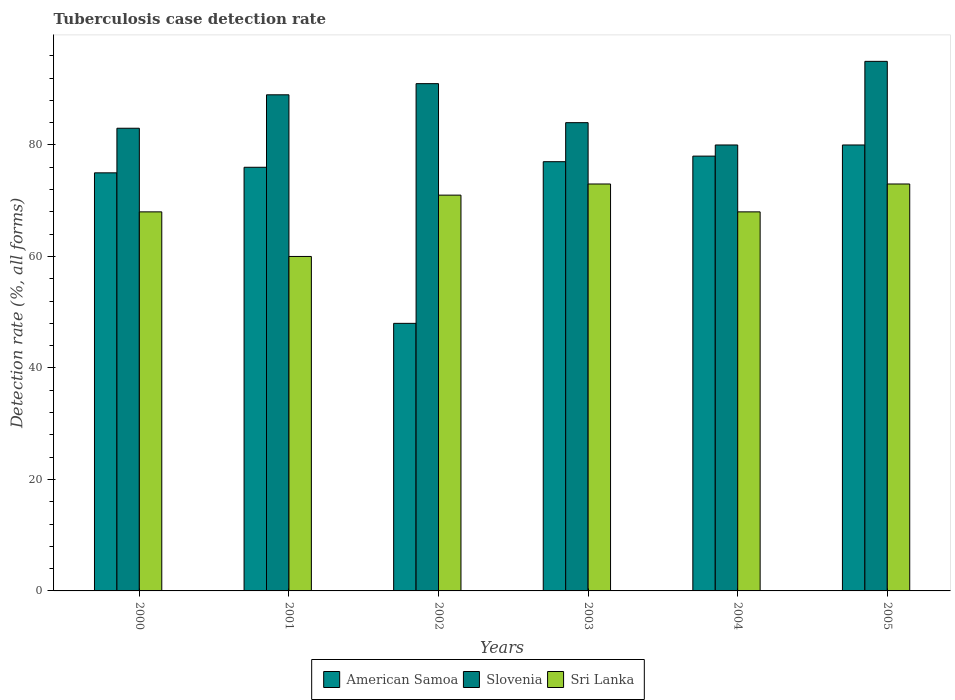How many different coloured bars are there?
Offer a very short reply. 3. How many groups of bars are there?
Ensure brevity in your answer.  6. Are the number of bars on each tick of the X-axis equal?
Provide a short and direct response. Yes. How many bars are there on the 5th tick from the right?
Offer a very short reply. 3. What is the label of the 5th group of bars from the left?
Give a very brief answer. 2004. In how many cases, is the number of bars for a given year not equal to the number of legend labels?
Provide a short and direct response. 0. What is the tuberculosis case detection rate in in American Samoa in 2005?
Offer a terse response. 80. Across all years, what is the minimum tuberculosis case detection rate in in American Samoa?
Keep it short and to the point. 48. In which year was the tuberculosis case detection rate in in Slovenia maximum?
Provide a short and direct response. 2005. What is the total tuberculosis case detection rate in in Sri Lanka in the graph?
Give a very brief answer. 413. What is the difference between the tuberculosis case detection rate in in Sri Lanka in 2001 and that in 2002?
Offer a very short reply. -11. What is the difference between the tuberculosis case detection rate in in American Samoa in 2003 and the tuberculosis case detection rate in in Slovenia in 2002?
Provide a short and direct response. -14. What is the average tuberculosis case detection rate in in American Samoa per year?
Offer a terse response. 72.33. In the year 2000, what is the difference between the tuberculosis case detection rate in in American Samoa and tuberculosis case detection rate in in Sri Lanka?
Your answer should be very brief. 7. In how many years, is the tuberculosis case detection rate in in Sri Lanka greater than 84 %?
Offer a terse response. 0. What is the ratio of the tuberculosis case detection rate in in Slovenia in 2000 to that in 2004?
Provide a succinct answer. 1.04. Is the difference between the tuberculosis case detection rate in in American Samoa in 2000 and 2004 greater than the difference between the tuberculosis case detection rate in in Sri Lanka in 2000 and 2004?
Give a very brief answer. No. What is the difference between the highest and the second highest tuberculosis case detection rate in in American Samoa?
Provide a succinct answer. 2. In how many years, is the tuberculosis case detection rate in in Slovenia greater than the average tuberculosis case detection rate in in Slovenia taken over all years?
Your answer should be compact. 3. Is the sum of the tuberculosis case detection rate in in American Samoa in 2003 and 2004 greater than the maximum tuberculosis case detection rate in in Sri Lanka across all years?
Make the answer very short. Yes. What does the 3rd bar from the left in 2000 represents?
Offer a very short reply. Sri Lanka. What does the 2nd bar from the right in 2005 represents?
Your response must be concise. Slovenia. Is it the case that in every year, the sum of the tuberculosis case detection rate in in Slovenia and tuberculosis case detection rate in in American Samoa is greater than the tuberculosis case detection rate in in Sri Lanka?
Provide a succinct answer. Yes. Are all the bars in the graph horizontal?
Give a very brief answer. No. What is the difference between two consecutive major ticks on the Y-axis?
Provide a succinct answer. 20. How are the legend labels stacked?
Offer a terse response. Horizontal. What is the title of the graph?
Give a very brief answer. Tuberculosis case detection rate. Does "Pacific island small states" appear as one of the legend labels in the graph?
Your response must be concise. No. What is the label or title of the Y-axis?
Provide a short and direct response. Detection rate (%, all forms). What is the Detection rate (%, all forms) in American Samoa in 2000?
Give a very brief answer. 75. What is the Detection rate (%, all forms) in Slovenia in 2000?
Your answer should be compact. 83. What is the Detection rate (%, all forms) of Sri Lanka in 2000?
Provide a short and direct response. 68. What is the Detection rate (%, all forms) in Slovenia in 2001?
Your answer should be compact. 89. What is the Detection rate (%, all forms) in Sri Lanka in 2001?
Provide a succinct answer. 60. What is the Detection rate (%, all forms) of American Samoa in 2002?
Keep it short and to the point. 48. What is the Detection rate (%, all forms) in Slovenia in 2002?
Offer a very short reply. 91. What is the Detection rate (%, all forms) of American Samoa in 2003?
Provide a succinct answer. 77. What is the Detection rate (%, all forms) in Sri Lanka in 2003?
Your answer should be compact. 73. What is the Detection rate (%, all forms) of Slovenia in 2004?
Provide a succinct answer. 80. What is the Detection rate (%, all forms) of Sri Lanka in 2004?
Make the answer very short. 68. What is the Detection rate (%, all forms) in Slovenia in 2005?
Offer a very short reply. 95. Across all years, what is the maximum Detection rate (%, all forms) in American Samoa?
Your answer should be compact. 80. Across all years, what is the maximum Detection rate (%, all forms) in Slovenia?
Your answer should be compact. 95. Across all years, what is the minimum Detection rate (%, all forms) of American Samoa?
Give a very brief answer. 48. Across all years, what is the minimum Detection rate (%, all forms) of Sri Lanka?
Your answer should be very brief. 60. What is the total Detection rate (%, all forms) of American Samoa in the graph?
Provide a short and direct response. 434. What is the total Detection rate (%, all forms) in Slovenia in the graph?
Offer a very short reply. 522. What is the total Detection rate (%, all forms) of Sri Lanka in the graph?
Your answer should be compact. 413. What is the difference between the Detection rate (%, all forms) in American Samoa in 2000 and that in 2001?
Offer a terse response. -1. What is the difference between the Detection rate (%, all forms) in Slovenia in 2000 and that in 2001?
Provide a succinct answer. -6. What is the difference between the Detection rate (%, all forms) of Slovenia in 2000 and that in 2002?
Give a very brief answer. -8. What is the difference between the Detection rate (%, all forms) of American Samoa in 2000 and that in 2005?
Make the answer very short. -5. What is the difference between the Detection rate (%, all forms) of Slovenia in 2001 and that in 2002?
Your response must be concise. -2. What is the difference between the Detection rate (%, all forms) of Sri Lanka in 2001 and that in 2002?
Make the answer very short. -11. What is the difference between the Detection rate (%, all forms) in American Samoa in 2001 and that in 2003?
Ensure brevity in your answer.  -1. What is the difference between the Detection rate (%, all forms) of American Samoa in 2001 and that in 2004?
Offer a terse response. -2. What is the difference between the Detection rate (%, all forms) in American Samoa in 2001 and that in 2005?
Your answer should be very brief. -4. What is the difference between the Detection rate (%, all forms) of Slovenia in 2001 and that in 2005?
Offer a very short reply. -6. What is the difference between the Detection rate (%, all forms) in American Samoa in 2002 and that in 2003?
Give a very brief answer. -29. What is the difference between the Detection rate (%, all forms) of Slovenia in 2002 and that in 2003?
Offer a terse response. 7. What is the difference between the Detection rate (%, all forms) of Sri Lanka in 2002 and that in 2003?
Provide a short and direct response. -2. What is the difference between the Detection rate (%, all forms) in Slovenia in 2002 and that in 2004?
Your answer should be compact. 11. What is the difference between the Detection rate (%, all forms) of Sri Lanka in 2002 and that in 2004?
Keep it short and to the point. 3. What is the difference between the Detection rate (%, all forms) in American Samoa in 2002 and that in 2005?
Your response must be concise. -32. What is the difference between the Detection rate (%, all forms) of Slovenia in 2002 and that in 2005?
Offer a terse response. -4. What is the difference between the Detection rate (%, all forms) in American Samoa in 2003 and that in 2004?
Your answer should be very brief. -1. What is the difference between the Detection rate (%, all forms) in Sri Lanka in 2003 and that in 2004?
Give a very brief answer. 5. What is the difference between the Detection rate (%, all forms) of Sri Lanka in 2003 and that in 2005?
Provide a short and direct response. 0. What is the difference between the Detection rate (%, all forms) of American Samoa in 2004 and that in 2005?
Provide a succinct answer. -2. What is the difference between the Detection rate (%, all forms) of Slovenia in 2004 and that in 2005?
Give a very brief answer. -15. What is the difference between the Detection rate (%, all forms) of American Samoa in 2000 and the Detection rate (%, all forms) of Sri Lanka in 2001?
Your answer should be very brief. 15. What is the difference between the Detection rate (%, all forms) of American Samoa in 2000 and the Detection rate (%, all forms) of Slovenia in 2003?
Offer a very short reply. -9. What is the difference between the Detection rate (%, all forms) in American Samoa in 2000 and the Detection rate (%, all forms) in Slovenia in 2005?
Your answer should be very brief. -20. What is the difference between the Detection rate (%, all forms) in American Samoa in 2000 and the Detection rate (%, all forms) in Sri Lanka in 2005?
Offer a terse response. 2. What is the difference between the Detection rate (%, all forms) in Slovenia in 2000 and the Detection rate (%, all forms) in Sri Lanka in 2005?
Your response must be concise. 10. What is the difference between the Detection rate (%, all forms) in Slovenia in 2001 and the Detection rate (%, all forms) in Sri Lanka in 2002?
Give a very brief answer. 18. What is the difference between the Detection rate (%, all forms) of American Samoa in 2001 and the Detection rate (%, all forms) of Slovenia in 2003?
Ensure brevity in your answer.  -8. What is the difference between the Detection rate (%, all forms) in Slovenia in 2001 and the Detection rate (%, all forms) in Sri Lanka in 2003?
Your response must be concise. 16. What is the difference between the Detection rate (%, all forms) in American Samoa in 2001 and the Detection rate (%, all forms) in Slovenia in 2004?
Provide a succinct answer. -4. What is the difference between the Detection rate (%, all forms) of American Samoa in 2001 and the Detection rate (%, all forms) of Sri Lanka in 2004?
Provide a succinct answer. 8. What is the difference between the Detection rate (%, all forms) of Slovenia in 2001 and the Detection rate (%, all forms) of Sri Lanka in 2004?
Make the answer very short. 21. What is the difference between the Detection rate (%, all forms) in American Samoa in 2001 and the Detection rate (%, all forms) in Slovenia in 2005?
Ensure brevity in your answer.  -19. What is the difference between the Detection rate (%, all forms) in American Samoa in 2002 and the Detection rate (%, all forms) in Slovenia in 2003?
Provide a succinct answer. -36. What is the difference between the Detection rate (%, all forms) in Slovenia in 2002 and the Detection rate (%, all forms) in Sri Lanka in 2003?
Provide a short and direct response. 18. What is the difference between the Detection rate (%, all forms) in American Samoa in 2002 and the Detection rate (%, all forms) in Slovenia in 2004?
Keep it short and to the point. -32. What is the difference between the Detection rate (%, all forms) of American Samoa in 2002 and the Detection rate (%, all forms) of Sri Lanka in 2004?
Offer a terse response. -20. What is the difference between the Detection rate (%, all forms) of Slovenia in 2002 and the Detection rate (%, all forms) of Sri Lanka in 2004?
Ensure brevity in your answer.  23. What is the difference between the Detection rate (%, all forms) of American Samoa in 2002 and the Detection rate (%, all forms) of Slovenia in 2005?
Offer a very short reply. -47. What is the difference between the Detection rate (%, all forms) in American Samoa in 2002 and the Detection rate (%, all forms) in Sri Lanka in 2005?
Ensure brevity in your answer.  -25. What is the difference between the Detection rate (%, all forms) in American Samoa in 2003 and the Detection rate (%, all forms) in Slovenia in 2004?
Ensure brevity in your answer.  -3. What is the difference between the Detection rate (%, all forms) of Slovenia in 2003 and the Detection rate (%, all forms) of Sri Lanka in 2004?
Your answer should be compact. 16. What is the difference between the Detection rate (%, all forms) of American Samoa in 2003 and the Detection rate (%, all forms) of Slovenia in 2005?
Provide a short and direct response. -18. What is the difference between the Detection rate (%, all forms) of American Samoa in 2003 and the Detection rate (%, all forms) of Sri Lanka in 2005?
Your response must be concise. 4. What is the difference between the Detection rate (%, all forms) of American Samoa in 2004 and the Detection rate (%, all forms) of Slovenia in 2005?
Keep it short and to the point. -17. What is the difference between the Detection rate (%, all forms) of American Samoa in 2004 and the Detection rate (%, all forms) of Sri Lanka in 2005?
Give a very brief answer. 5. What is the average Detection rate (%, all forms) in American Samoa per year?
Make the answer very short. 72.33. What is the average Detection rate (%, all forms) in Slovenia per year?
Give a very brief answer. 87. What is the average Detection rate (%, all forms) in Sri Lanka per year?
Provide a succinct answer. 68.83. In the year 2000, what is the difference between the Detection rate (%, all forms) of American Samoa and Detection rate (%, all forms) of Slovenia?
Your response must be concise. -8. In the year 2000, what is the difference between the Detection rate (%, all forms) in American Samoa and Detection rate (%, all forms) in Sri Lanka?
Ensure brevity in your answer.  7. In the year 2001, what is the difference between the Detection rate (%, all forms) of American Samoa and Detection rate (%, all forms) of Sri Lanka?
Make the answer very short. 16. In the year 2002, what is the difference between the Detection rate (%, all forms) in American Samoa and Detection rate (%, all forms) in Slovenia?
Provide a short and direct response. -43. In the year 2002, what is the difference between the Detection rate (%, all forms) of Slovenia and Detection rate (%, all forms) of Sri Lanka?
Provide a short and direct response. 20. In the year 2003, what is the difference between the Detection rate (%, all forms) in American Samoa and Detection rate (%, all forms) in Slovenia?
Give a very brief answer. -7. In the year 2003, what is the difference between the Detection rate (%, all forms) of American Samoa and Detection rate (%, all forms) of Sri Lanka?
Ensure brevity in your answer.  4. In the year 2004, what is the difference between the Detection rate (%, all forms) in American Samoa and Detection rate (%, all forms) in Slovenia?
Keep it short and to the point. -2. In the year 2004, what is the difference between the Detection rate (%, all forms) of Slovenia and Detection rate (%, all forms) of Sri Lanka?
Provide a succinct answer. 12. In the year 2005, what is the difference between the Detection rate (%, all forms) of Slovenia and Detection rate (%, all forms) of Sri Lanka?
Give a very brief answer. 22. What is the ratio of the Detection rate (%, all forms) in Slovenia in 2000 to that in 2001?
Make the answer very short. 0.93. What is the ratio of the Detection rate (%, all forms) in Sri Lanka in 2000 to that in 2001?
Provide a short and direct response. 1.13. What is the ratio of the Detection rate (%, all forms) of American Samoa in 2000 to that in 2002?
Provide a short and direct response. 1.56. What is the ratio of the Detection rate (%, all forms) of Slovenia in 2000 to that in 2002?
Keep it short and to the point. 0.91. What is the ratio of the Detection rate (%, all forms) in Sri Lanka in 2000 to that in 2002?
Ensure brevity in your answer.  0.96. What is the ratio of the Detection rate (%, all forms) in Slovenia in 2000 to that in 2003?
Give a very brief answer. 0.99. What is the ratio of the Detection rate (%, all forms) in Sri Lanka in 2000 to that in 2003?
Offer a terse response. 0.93. What is the ratio of the Detection rate (%, all forms) of American Samoa in 2000 to that in 2004?
Ensure brevity in your answer.  0.96. What is the ratio of the Detection rate (%, all forms) in Slovenia in 2000 to that in 2004?
Your answer should be very brief. 1.04. What is the ratio of the Detection rate (%, all forms) in Sri Lanka in 2000 to that in 2004?
Provide a short and direct response. 1. What is the ratio of the Detection rate (%, all forms) of American Samoa in 2000 to that in 2005?
Your answer should be compact. 0.94. What is the ratio of the Detection rate (%, all forms) in Slovenia in 2000 to that in 2005?
Provide a succinct answer. 0.87. What is the ratio of the Detection rate (%, all forms) of Sri Lanka in 2000 to that in 2005?
Your answer should be very brief. 0.93. What is the ratio of the Detection rate (%, all forms) in American Samoa in 2001 to that in 2002?
Provide a short and direct response. 1.58. What is the ratio of the Detection rate (%, all forms) of Sri Lanka in 2001 to that in 2002?
Your answer should be very brief. 0.85. What is the ratio of the Detection rate (%, all forms) of Slovenia in 2001 to that in 2003?
Keep it short and to the point. 1.06. What is the ratio of the Detection rate (%, all forms) in Sri Lanka in 2001 to that in 2003?
Give a very brief answer. 0.82. What is the ratio of the Detection rate (%, all forms) in American Samoa in 2001 to that in 2004?
Offer a very short reply. 0.97. What is the ratio of the Detection rate (%, all forms) of Slovenia in 2001 to that in 2004?
Provide a short and direct response. 1.11. What is the ratio of the Detection rate (%, all forms) in Sri Lanka in 2001 to that in 2004?
Keep it short and to the point. 0.88. What is the ratio of the Detection rate (%, all forms) of American Samoa in 2001 to that in 2005?
Ensure brevity in your answer.  0.95. What is the ratio of the Detection rate (%, all forms) in Slovenia in 2001 to that in 2005?
Offer a terse response. 0.94. What is the ratio of the Detection rate (%, all forms) in Sri Lanka in 2001 to that in 2005?
Ensure brevity in your answer.  0.82. What is the ratio of the Detection rate (%, all forms) in American Samoa in 2002 to that in 2003?
Provide a short and direct response. 0.62. What is the ratio of the Detection rate (%, all forms) in Sri Lanka in 2002 to that in 2003?
Give a very brief answer. 0.97. What is the ratio of the Detection rate (%, all forms) of American Samoa in 2002 to that in 2004?
Offer a very short reply. 0.62. What is the ratio of the Detection rate (%, all forms) of Slovenia in 2002 to that in 2004?
Offer a very short reply. 1.14. What is the ratio of the Detection rate (%, all forms) of Sri Lanka in 2002 to that in 2004?
Provide a short and direct response. 1.04. What is the ratio of the Detection rate (%, all forms) of Slovenia in 2002 to that in 2005?
Your answer should be compact. 0.96. What is the ratio of the Detection rate (%, all forms) in Sri Lanka in 2002 to that in 2005?
Ensure brevity in your answer.  0.97. What is the ratio of the Detection rate (%, all forms) of American Samoa in 2003 to that in 2004?
Make the answer very short. 0.99. What is the ratio of the Detection rate (%, all forms) of Slovenia in 2003 to that in 2004?
Your answer should be compact. 1.05. What is the ratio of the Detection rate (%, all forms) in Sri Lanka in 2003 to that in 2004?
Provide a succinct answer. 1.07. What is the ratio of the Detection rate (%, all forms) in American Samoa in 2003 to that in 2005?
Your response must be concise. 0.96. What is the ratio of the Detection rate (%, all forms) in Slovenia in 2003 to that in 2005?
Your response must be concise. 0.88. What is the ratio of the Detection rate (%, all forms) in Sri Lanka in 2003 to that in 2005?
Provide a short and direct response. 1. What is the ratio of the Detection rate (%, all forms) of Slovenia in 2004 to that in 2005?
Ensure brevity in your answer.  0.84. What is the ratio of the Detection rate (%, all forms) in Sri Lanka in 2004 to that in 2005?
Offer a terse response. 0.93. What is the difference between the highest and the second highest Detection rate (%, all forms) in American Samoa?
Your response must be concise. 2. What is the difference between the highest and the lowest Detection rate (%, all forms) of Slovenia?
Your answer should be very brief. 15. 